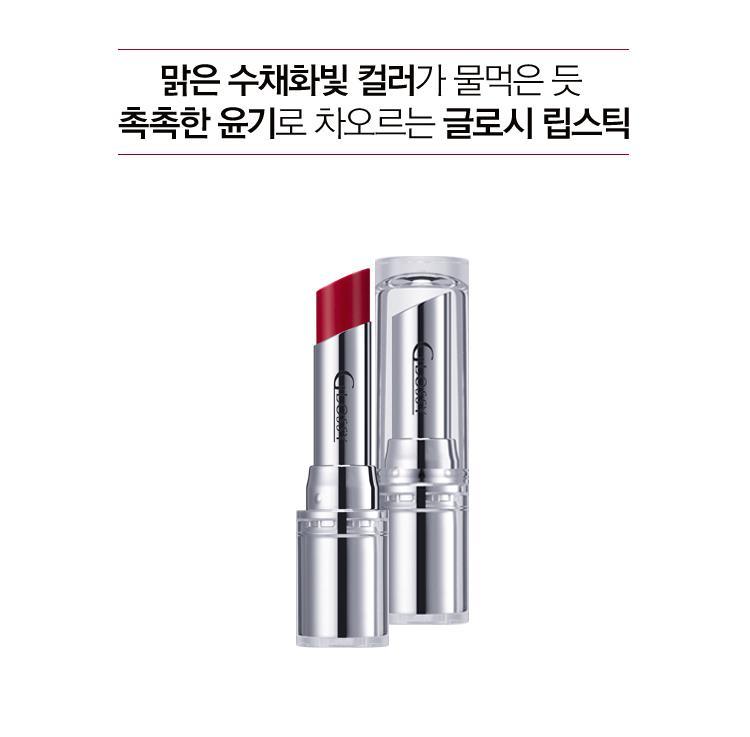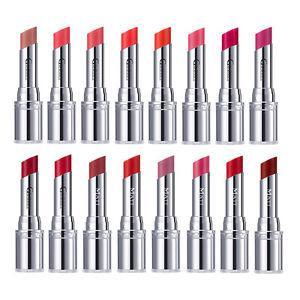The first image is the image on the left, the second image is the image on the right. Examine the images to the left and right. Is the description "The lipstick in the right photo has a black case." accurate? Answer yes or no. No. The first image is the image on the left, the second image is the image on the right. Examine the images to the left and right. Is the description "Each image shows just one lipstick next to its cap." accurate? Answer yes or no. No. 